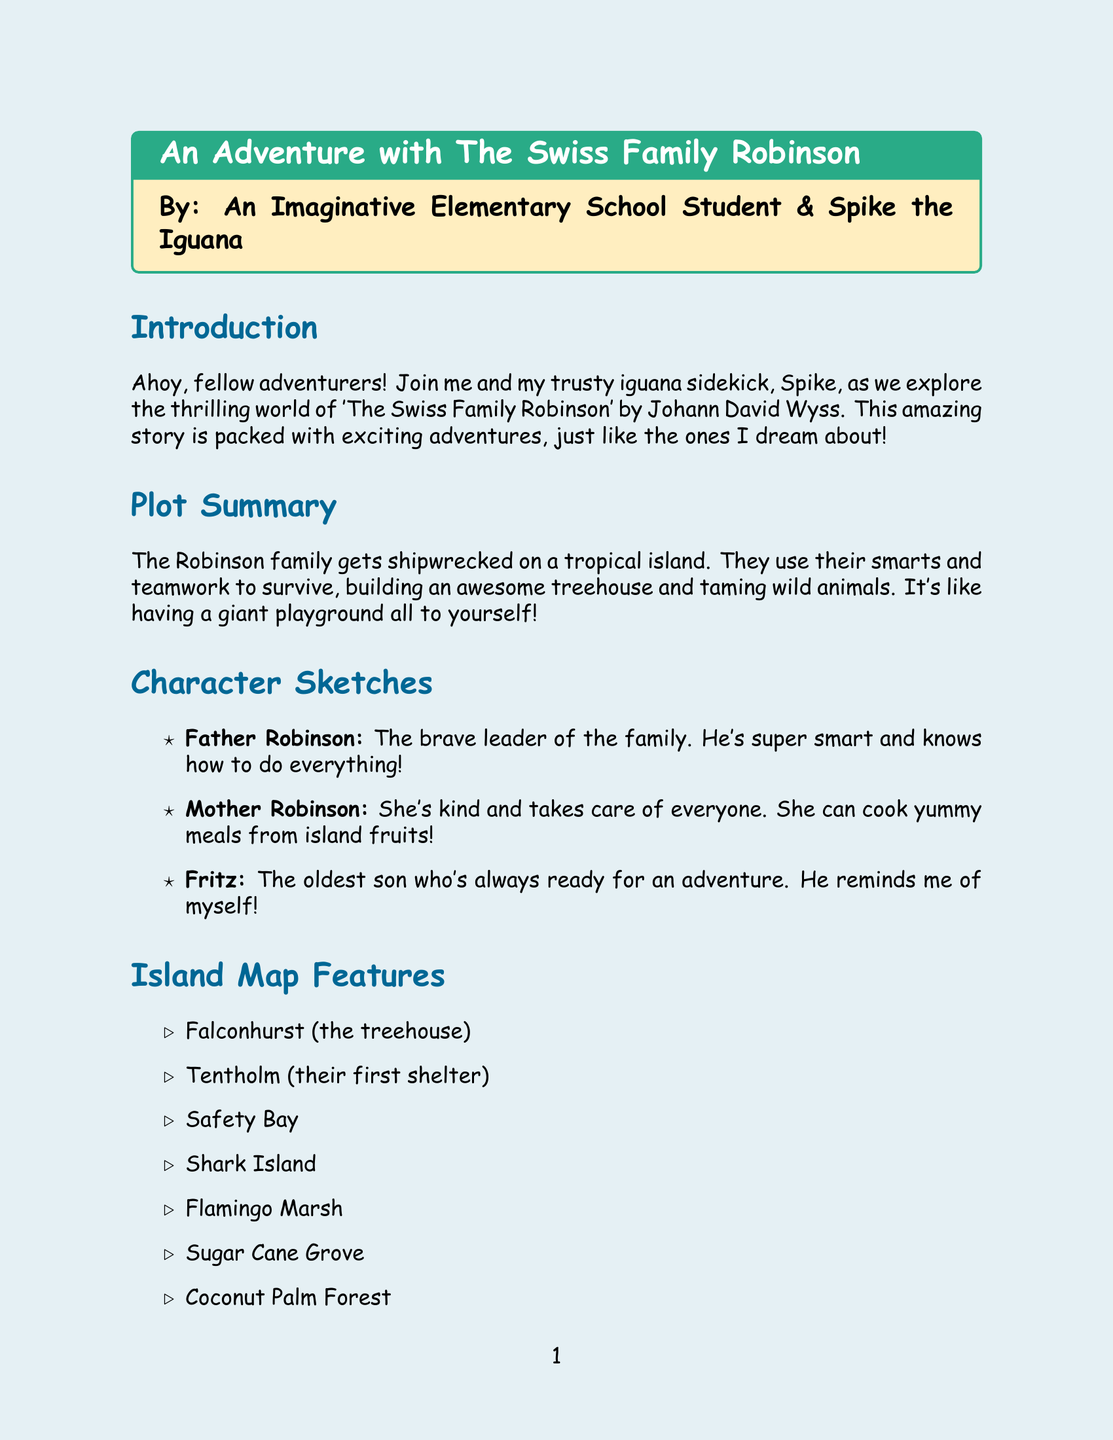What is the title of the book? The title is mentioned at the beginning of the document in the tcolorbox.
Answer: The Swiss Family Robinson Who is the author of the book? The author is listed in the introduction section of the report.
Answer: Johann David Wyss What is the name of the oldest son in the Robinson family? Fritz's name is mentioned under the character sketches section.
Answer: Fritz What does the island's treehouse get named? The name of the treehouse appears in the list of map features.
Answer: Falconhurst What animal is mentioned alongside Fritz in his sketch idea? The character sketch mentions a pet alongside Fritz.
Answer: Monkey How many favorite parts of the story are listed? There are three favorite parts listed in the document under the respective section.
Answer: 3 What is one lesson learned from the book? The lessons learned are summarized at the end of the document in a list format.
Answer: Working together as a family is important What color will be used for the ocean on the island map? The color for the ocean is specified in the map description section.
Answer: Blue Which character is described as kind and takes care of everyone? This description is found in the character sketches section, detailing one of the family members.
Answer: Mother Robinson 